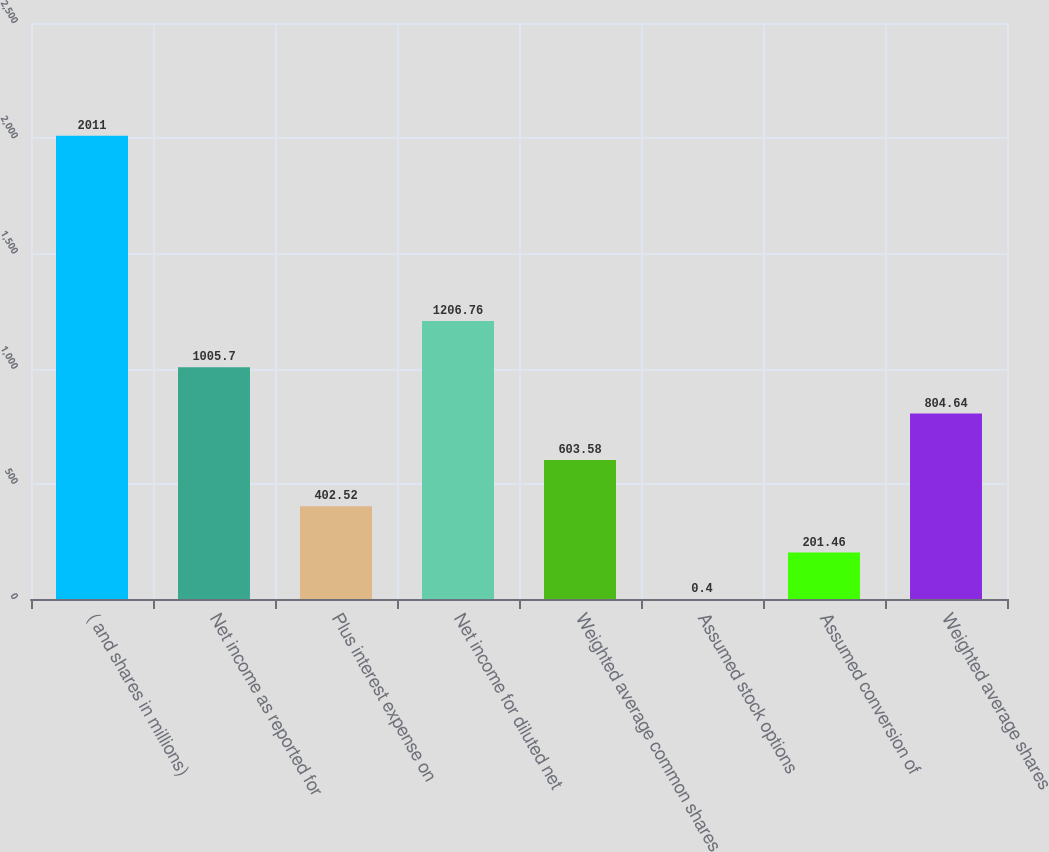<chart> <loc_0><loc_0><loc_500><loc_500><bar_chart><fcel>( and shares in millions)<fcel>Net income as reported for<fcel>Plus interest expense on<fcel>Net income for diluted net<fcel>Weighted average common shares<fcel>Assumed stock options<fcel>Assumed conversion of<fcel>Weighted average shares<nl><fcel>2011<fcel>1005.7<fcel>402.52<fcel>1206.76<fcel>603.58<fcel>0.4<fcel>201.46<fcel>804.64<nl></chart> 